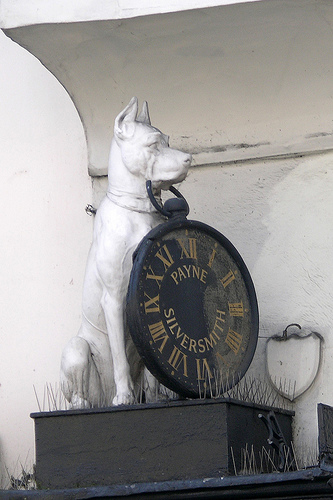<image>
Is there a dog above the table? No. The dog is not positioned above the table. The vertical arrangement shows a different relationship. 